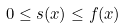Convert formula to latex. <formula><loc_0><loc_0><loc_500><loc_500>0 \leq s ( x ) \leq f ( x )</formula> 